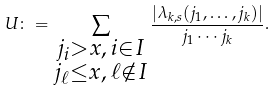Convert formula to latex. <formula><loc_0><loc_0><loc_500><loc_500>U \colon = \sum _ { \substack { j _ { i } > x , \, i \in I \\ j _ { \ell } \leq x , \, \ell \notin I } } \frac { | \lambda _ { k , s } ( j _ { 1 } , \dots , j _ { k } ) | } { j _ { 1 } \cdots j _ { k } } .</formula> 